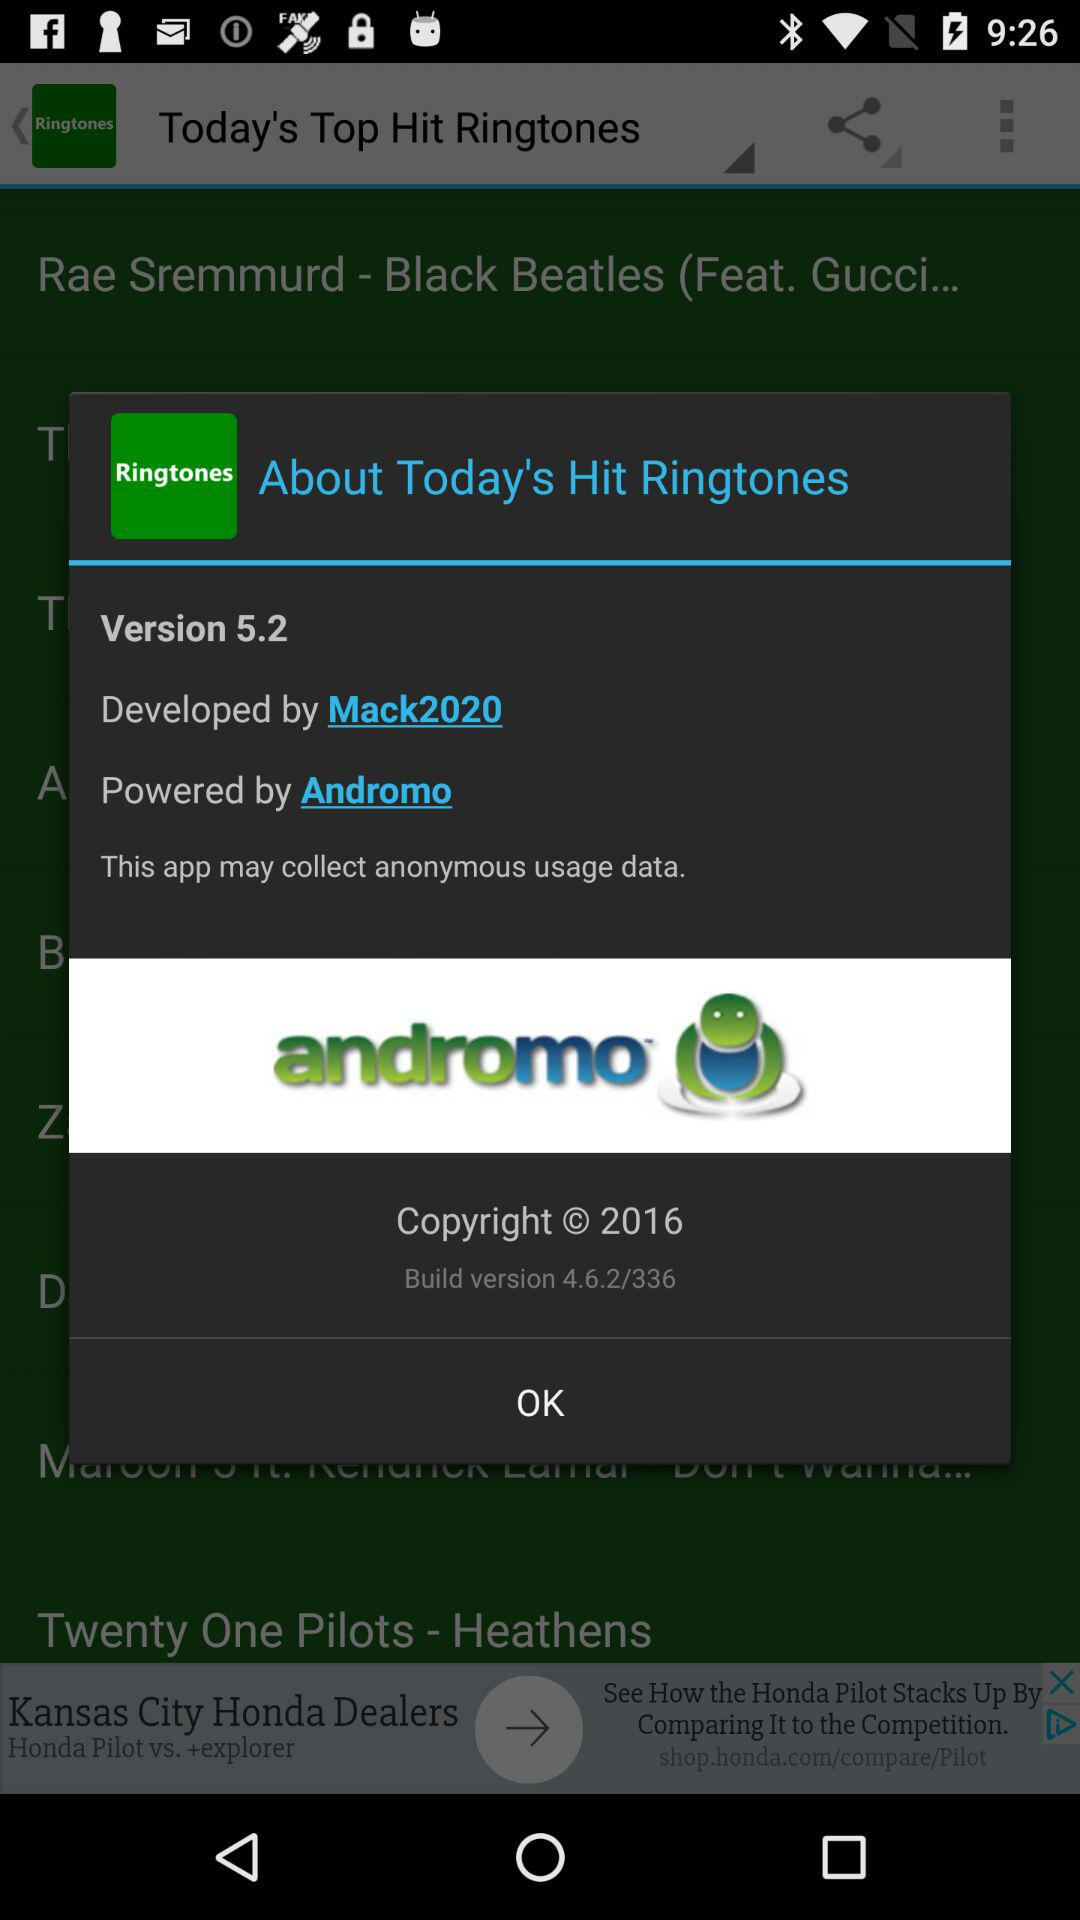What's the build version? The build version is 4.6.2/336. 